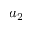Convert formula to latex. <formula><loc_0><loc_0><loc_500><loc_500>a _ { 2 }</formula> 